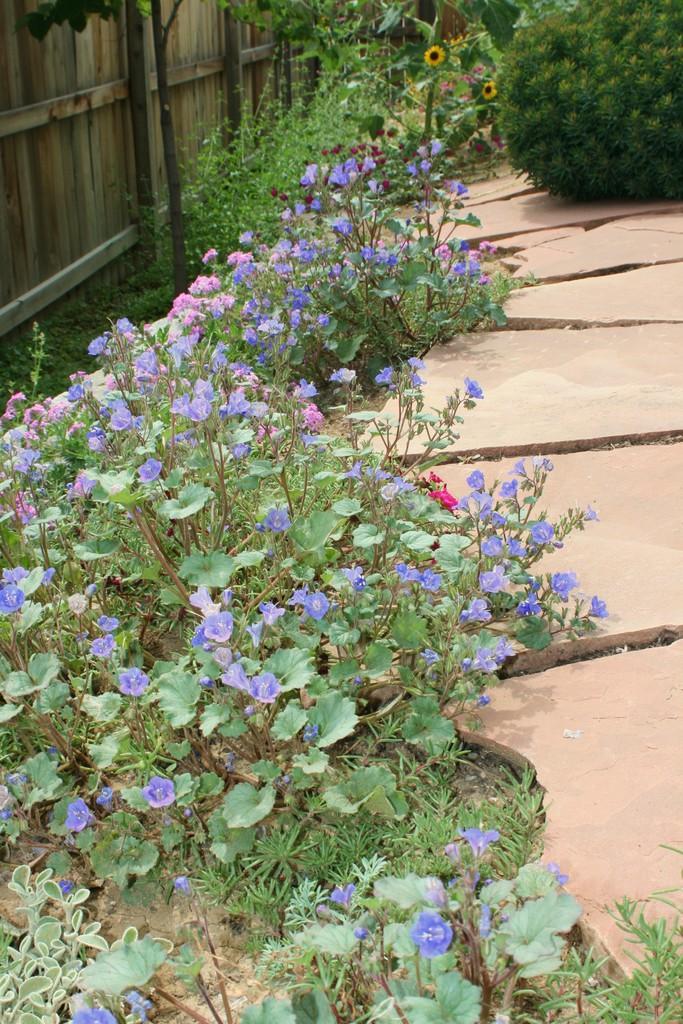Please provide a concise description of this image. In this image we can see the planets, path, grass and also the wooden fence. 